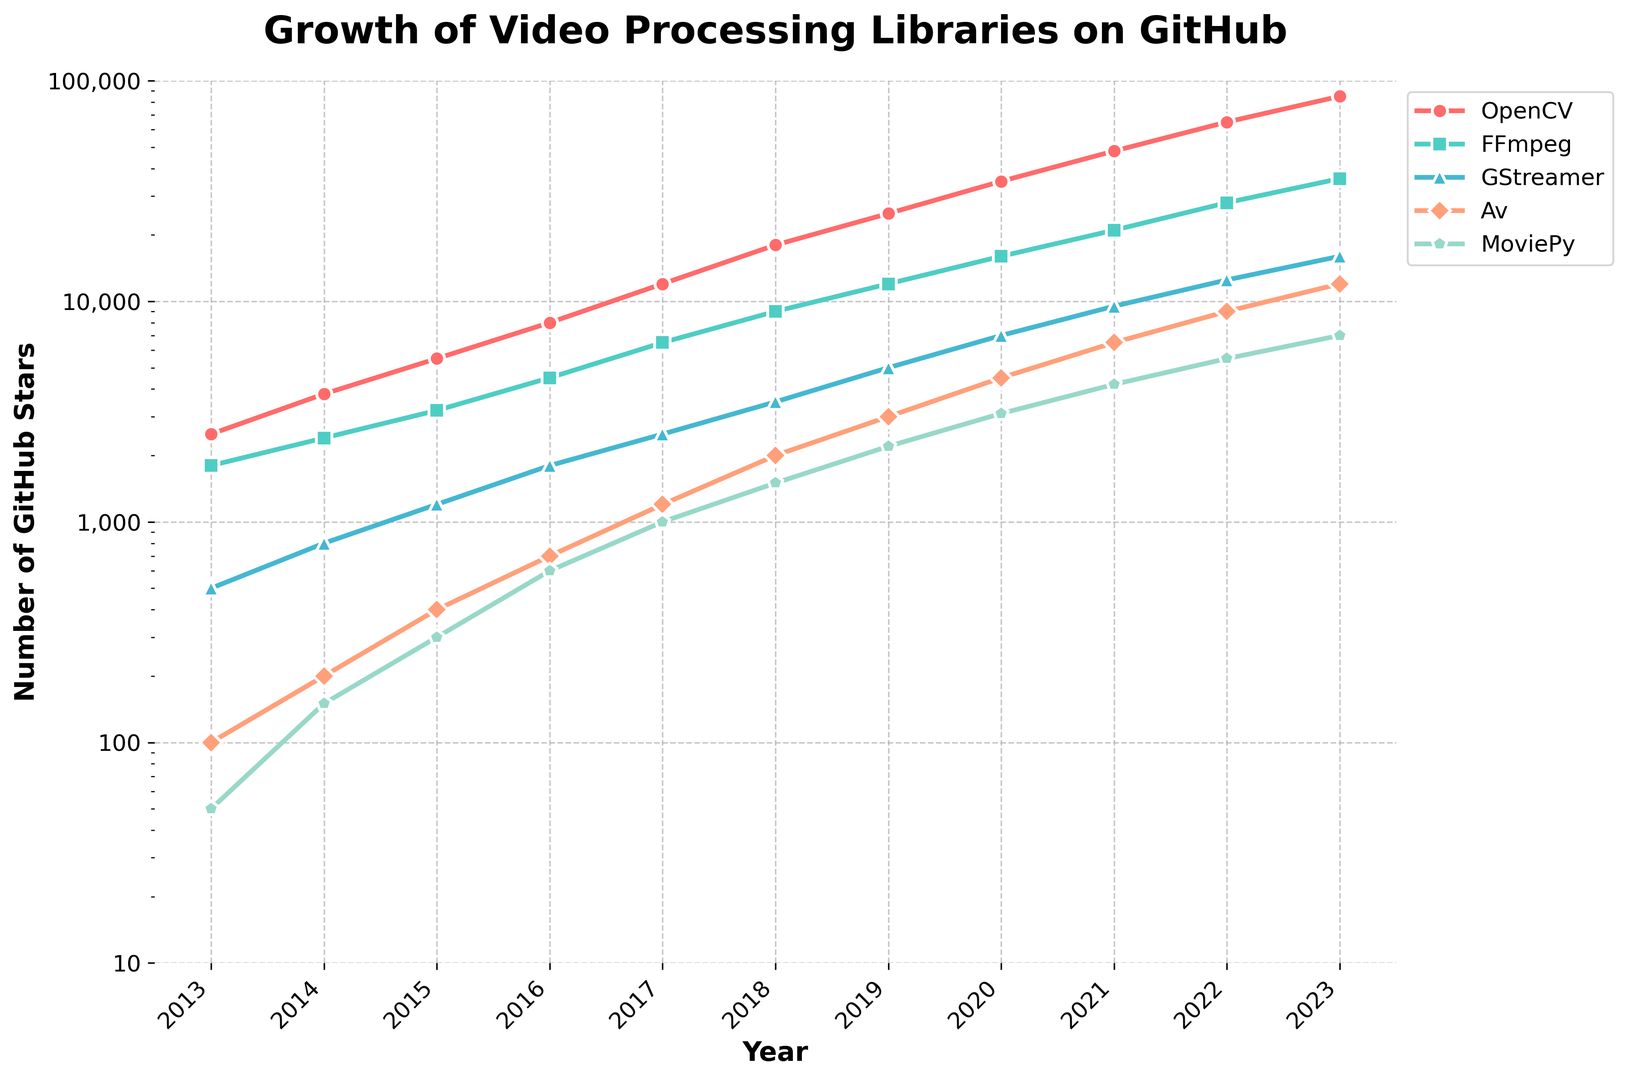Which library had the highest number of GitHub stars in 2023? Look at the number of stars for each library in 2023 and identify the one with the highest value.
Answer: OpenCV Which two libraries had the smallest increase in stars from 2018 to 2023? Calculate the difference in the number of stars from 2018 to 2023 for each library and compare them.
Answer: GStreamer and MoviePy How many times more stars did OpenCV have in 2023 compared to Av in 2023? Divide the number of stars OpenCV had in 2023 by the number of stars Av had in 2023.
Answer: Around 7 Which year did OpenCV first surpass FFmpeg in the number of stars? Compare the number of stars between OpenCV and FFmpeg for each year and find the first year when OpenCV's value is higher.
Answer: 2015 What is the average annual increase in stars for MoviePy from 2013 to 2023? Subtract the number of stars in 2013 from 2023 for MoviePy, then divide by the number of years (2023-2013).
Answer: Around 695 Which library had the steepest growth between 2016 and 2019? Calculate the growth (difference in the number of stars) between 2016 and 2019 for each library and identify the one with the greatest increase.
Answer: OpenCV By how much did the stars of FFmpeg grow from 2017 to 2020? Subtract the number of stars in 2017 from the number of stars in 2020 for FFmpeg.
Answer: 9500 In 2020, which library had the second highest number of stars? Look at the number of stars for each library in 2020 and identify the one with the second highest value.
Answer: FFmpeg How does the star count of GStreamer in 2022 compare to MoviePy in 2022? Compare the number of stars for GStreamer and MoviePy in 2022 directly.
Answer: GStreamer has more Did the number of stars for Av ever surpass GStreamer? Compare the number of stars for Av and GStreamer for each year to see if Av ever had a higher value.
Answer: No 